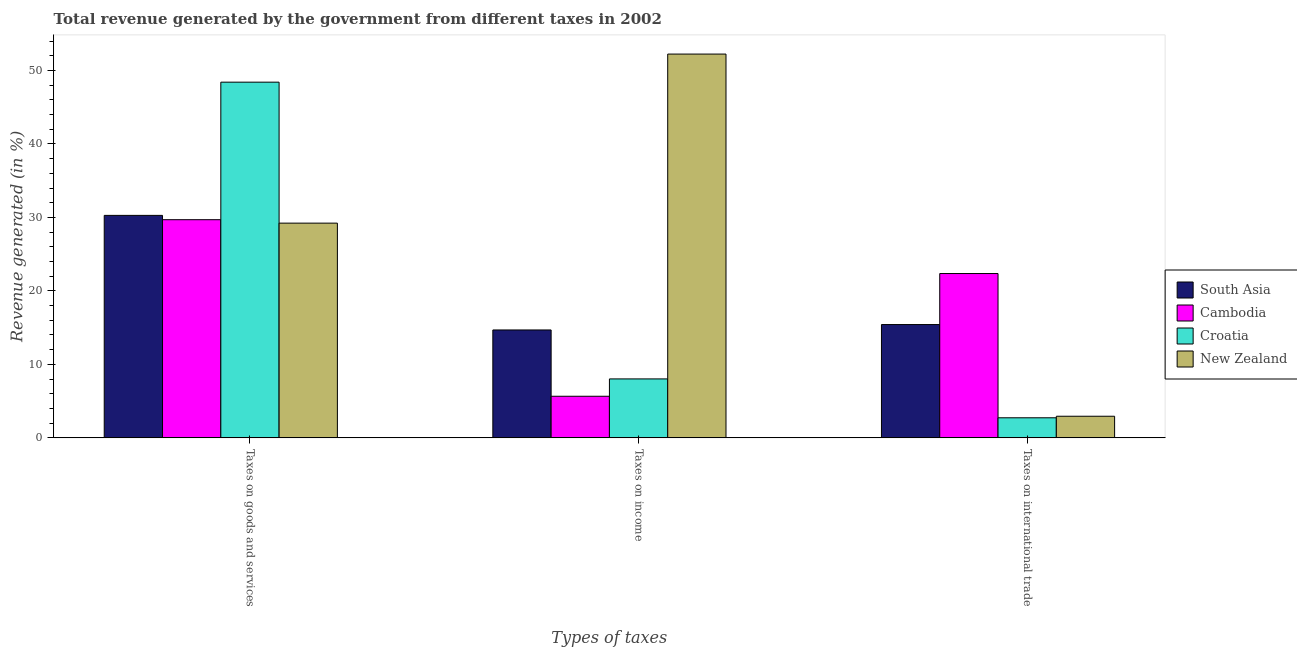How many groups of bars are there?
Keep it short and to the point. 3. How many bars are there on the 3rd tick from the left?
Ensure brevity in your answer.  4. How many bars are there on the 3rd tick from the right?
Ensure brevity in your answer.  4. What is the label of the 1st group of bars from the left?
Offer a terse response. Taxes on goods and services. What is the percentage of revenue generated by tax on international trade in Croatia?
Offer a terse response. 2.73. Across all countries, what is the maximum percentage of revenue generated by taxes on goods and services?
Give a very brief answer. 48.41. Across all countries, what is the minimum percentage of revenue generated by taxes on income?
Make the answer very short. 5.66. In which country was the percentage of revenue generated by tax on international trade maximum?
Offer a terse response. Cambodia. In which country was the percentage of revenue generated by taxes on goods and services minimum?
Your response must be concise. New Zealand. What is the total percentage of revenue generated by tax on international trade in the graph?
Give a very brief answer. 43.46. What is the difference between the percentage of revenue generated by taxes on income in Croatia and that in South Asia?
Provide a succinct answer. -6.66. What is the difference between the percentage of revenue generated by tax on international trade in South Asia and the percentage of revenue generated by taxes on income in New Zealand?
Ensure brevity in your answer.  -36.81. What is the average percentage of revenue generated by taxes on income per country?
Provide a short and direct response. 20.15. What is the difference between the percentage of revenue generated by taxes on income and percentage of revenue generated by tax on international trade in South Asia?
Offer a terse response. -0.74. What is the ratio of the percentage of revenue generated by taxes on income in New Zealand to that in Croatia?
Give a very brief answer. 6.51. Is the difference between the percentage of revenue generated by tax on international trade in New Zealand and South Asia greater than the difference between the percentage of revenue generated by taxes on income in New Zealand and South Asia?
Your answer should be very brief. No. What is the difference between the highest and the second highest percentage of revenue generated by taxes on goods and services?
Your answer should be compact. 18.13. What is the difference between the highest and the lowest percentage of revenue generated by taxes on income?
Give a very brief answer. 46.57. Is the sum of the percentage of revenue generated by taxes on income in New Zealand and Croatia greater than the maximum percentage of revenue generated by taxes on goods and services across all countries?
Your answer should be very brief. Yes. What does the 3rd bar from the left in Taxes on income represents?
Offer a terse response. Croatia. What does the 2nd bar from the right in Taxes on income represents?
Give a very brief answer. Croatia. How many bars are there?
Keep it short and to the point. 12. How many countries are there in the graph?
Your answer should be very brief. 4. What is the difference between two consecutive major ticks on the Y-axis?
Ensure brevity in your answer.  10. Are the values on the major ticks of Y-axis written in scientific E-notation?
Provide a short and direct response. No. Does the graph contain any zero values?
Offer a very short reply. No. Does the graph contain grids?
Make the answer very short. No. How are the legend labels stacked?
Your answer should be very brief. Vertical. What is the title of the graph?
Your response must be concise. Total revenue generated by the government from different taxes in 2002. Does "Cuba" appear as one of the legend labels in the graph?
Your response must be concise. No. What is the label or title of the X-axis?
Ensure brevity in your answer.  Types of taxes. What is the label or title of the Y-axis?
Provide a succinct answer. Revenue generated (in %). What is the Revenue generated (in %) of South Asia in Taxes on goods and services?
Your response must be concise. 30.28. What is the Revenue generated (in %) in Cambodia in Taxes on goods and services?
Your answer should be very brief. 29.69. What is the Revenue generated (in %) of Croatia in Taxes on goods and services?
Make the answer very short. 48.41. What is the Revenue generated (in %) of New Zealand in Taxes on goods and services?
Your response must be concise. 29.22. What is the Revenue generated (in %) in South Asia in Taxes on income?
Provide a short and direct response. 14.68. What is the Revenue generated (in %) of Cambodia in Taxes on income?
Your answer should be compact. 5.66. What is the Revenue generated (in %) in Croatia in Taxes on income?
Provide a short and direct response. 8.02. What is the Revenue generated (in %) of New Zealand in Taxes on income?
Your answer should be compact. 52.23. What is the Revenue generated (in %) of South Asia in Taxes on international trade?
Make the answer very short. 15.42. What is the Revenue generated (in %) of Cambodia in Taxes on international trade?
Your response must be concise. 22.36. What is the Revenue generated (in %) of Croatia in Taxes on international trade?
Make the answer very short. 2.73. What is the Revenue generated (in %) of New Zealand in Taxes on international trade?
Your answer should be compact. 2.94. Across all Types of taxes, what is the maximum Revenue generated (in %) in South Asia?
Your answer should be very brief. 30.28. Across all Types of taxes, what is the maximum Revenue generated (in %) in Cambodia?
Keep it short and to the point. 29.69. Across all Types of taxes, what is the maximum Revenue generated (in %) in Croatia?
Offer a very short reply. 48.41. Across all Types of taxes, what is the maximum Revenue generated (in %) in New Zealand?
Your answer should be compact. 52.23. Across all Types of taxes, what is the minimum Revenue generated (in %) in South Asia?
Provide a succinct answer. 14.68. Across all Types of taxes, what is the minimum Revenue generated (in %) of Cambodia?
Your answer should be very brief. 5.66. Across all Types of taxes, what is the minimum Revenue generated (in %) in Croatia?
Give a very brief answer. 2.73. Across all Types of taxes, what is the minimum Revenue generated (in %) in New Zealand?
Ensure brevity in your answer.  2.94. What is the total Revenue generated (in %) of South Asia in the graph?
Your response must be concise. 60.38. What is the total Revenue generated (in %) in Cambodia in the graph?
Offer a terse response. 57.72. What is the total Revenue generated (in %) in Croatia in the graph?
Offer a very short reply. 59.16. What is the total Revenue generated (in %) in New Zealand in the graph?
Provide a short and direct response. 84.39. What is the difference between the Revenue generated (in %) in South Asia in Taxes on goods and services and that in Taxes on income?
Provide a succinct answer. 15.59. What is the difference between the Revenue generated (in %) in Cambodia in Taxes on goods and services and that in Taxes on income?
Keep it short and to the point. 24.03. What is the difference between the Revenue generated (in %) of Croatia in Taxes on goods and services and that in Taxes on income?
Offer a very short reply. 40.38. What is the difference between the Revenue generated (in %) in New Zealand in Taxes on goods and services and that in Taxes on income?
Make the answer very short. -23.01. What is the difference between the Revenue generated (in %) in South Asia in Taxes on goods and services and that in Taxes on international trade?
Give a very brief answer. 14.86. What is the difference between the Revenue generated (in %) of Cambodia in Taxes on goods and services and that in Taxes on international trade?
Offer a terse response. 7.33. What is the difference between the Revenue generated (in %) in Croatia in Taxes on goods and services and that in Taxes on international trade?
Your answer should be very brief. 45.67. What is the difference between the Revenue generated (in %) of New Zealand in Taxes on goods and services and that in Taxes on international trade?
Keep it short and to the point. 26.28. What is the difference between the Revenue generated (in %) in South Asia in Taxes on income and that in Taxes on international trade?
Keep it short and to the point. -0.74. What is the difference between the Revenue generated (in %) in Cambodia in Taxes on income and that in Taxes on international trade?
Keep it short and to the point. -16.7. What is the difference between the Revenue generated (in %) in Croatia in Taxes on income and that in Taxes on international trade?
Your answer should be compact. 5.29. What is the difference between the Revenue generated (in %) of New Zealand in Taxes on income and that in Taxes on international trade?
Offer a terse response. 49.28. What is the difference between the Revenue generated (in %) in South Asia in Taxes on goods and services and the Revenue generated (in %) in Cambodia in Taxes on income?
Your response must be concise. 24.61. What is the difference between the Revenue generated (in %) of South Asia in Taxes on goods and services and the Revenue generated (in %) of Croatia in Taxes on income?
Ensure brevity in your answer.  22.25. What is the difference between the Revenue generated (in %) of South Asia in Taxes on goods and services and the Revenue generated (in %) of New Zealand in Taxes on income?
Your answer should be compact. -21.95. What is the difference between the Revenue generated (in %) in Cambodia in Taxes on goods and services and the Revenue generated (in %) in Croatia in Taxes on income?
Make the answer very short. 21.67. What is the difference between the Revenue generated (in %) in Cambodia in Taxes on goods and services and the Revenue generated (in %) in New Zealand in Taxes on income?
Offer a very short reply. -22.54. What is the difference between the Revenue generated (in %) of Croatia in Taxes on goods and services and the Revenue generated (in %) of New Zealand in Taxes on income?
Keep it short and to the point. -3.82. What is the difference between the Revenue generated (in %) in South Asia in Taxes on goods and services and the Revenue generated (in %) in Cambodia in Taxes on international trade?
Your answer should be very brief. 7.91. What is the difference between the Revenue generated (in %) of South Asia in Taxes on goods and services and the Revenue generated (in %) of Croatia in Taxes on international trade?
Keep it short and to the point. 27.54. What is the difference between the Revenue generated (in %) in South Asia in Taxes on goods and services and the Revenue generated (in %) in New Zealand in Taxes on international trade?
Your answer should be very brief. 27.33. What is the difference between the Revenue generated (in %) in Cambodia in Taxes on goods and services and the Revenue generated (in %) in Croatia in Taxes on international trade?
Your answer should be very brief. 26.96. What is the difference between the Revenue generated (in %) in Cambodia in Taxes on goods and services and the Revenue generated (in %) in New Zealand in Taxes on international trade?
Offer a terse response. 26.75. What is the difference between the Revenue generated (in %) in Croatia in Taxes on goods and services and the Revenue generated (in %) in New Zealand in Taxes on international trade?
Offer a terse response. 45.46. What is the difference between the Revenue generated (in %) in South Asia in Taxes on income and the Revenue generated (in %) in Cambodia in Taxes on international trade?
Offer a very short reply. -7.68. What is the difference between the Revenue generated (in %) of South Asia in Taxes on income and the Revenue generated (in %) of Croatia in Taxes on international trade?
Provide a short and direct response. 11.95. What is the difference between the Revenue generated (in %) of South Asia in Taxes on income and the Revenue generated (in %) of New Zealand in Taxes on international trade?
Offer a very short reply. 11.74. What is the difference between the Revenue generated (in %) in Cambodia in Taxes on income and the Revenue generated (in %) in Croatia in Taxes on international trade?
Make the answer very short. 2.93. What is the difference between the Revenue generated (in %) in Cambodia in Taxes on income and the Revenue generated (in %) in New Zealand in Taxes on international trade?
Provide a short and direct response. 2.72. What is the difference between the Revenue generated (in %) in Croatia in Taxes on income and the Revenue generated (in %) in New Zealand in Taxes on international trade?
Your answer should be very brief. 5.08. What is the average Revenue generated (in %) in South Asia per Types of taxes?
Offer a terse response. 20.13. What is the average Revenue generated (in %) of Cambodia per Types of taxes?
Give a very brief answer. 19.24. What is the average Revenue generated (in %) in Croatia per Types of taxes?
Give a very brief answer. 19.72. What is the average Revenue generated (in %) in New Zealand per Types of taxes?
Provide a short and direct response. 28.13. What is the difference between the Revenue generated (in %) in South Asia and Revenue generated (in %) in Cambodia in Taxes on goods and services?
Give a very brief answer. 0.59. What is the difference between the Revenue generated (in %) in South Asia and Revenue generated (in %) in Croatia in Taxes on goods and services?
Your answer should be very brief. -18.13. What is the difference between the Revenue generated (in %) of South Asia and Revenue generated (in %) of New Zealand in Taxes on goods and services?
Offer a terse response. 1.05. What is the difference between the Revenue generated (in %) of Cambodia and Revenue generated (in %) of Croatia in Taxes on goods and services?
Keep it short and to the point. -18.72. What is the difference between the Revenue generated (in %) of Cambodia and Revenue generated (in %) of New Zealand in Taxes on goods and services?
Keep it short and to the point. 0.47. What is the difference between the Revenue generated (in %) in Croatia and Revenue generated (in %) in New Zealand in Taxes on goods and services?
Give a very brief answer. 19.18. What is the difference between the Revenue generated (in %) in South Asia and Revenue generated (in %) in Cambodia in Taxes on income?
Offer a terse response. 9.02. What is the difference between the Revenue generated (in %) in South Asia and Revenue generated (in %) in Croatia in Taxes on income?
Provide a short and direct response. 6.66. What is the difference between the Revenue generated (in %) in South Asia and Revenue generated (in %) in New Zealand in Taxes on income?
Offer a very short reply. -37.54. What is the difference between the Revenue generated (in %) in Cambodia and Revenue generated (in %) in Croatia in Taxes on income?
Offer a very short reply. -2.36. What is the difference between the Revenue generated (in %) in Cambodia and Revenue generated (in %) in New Zealand in Taxes on income?
Make the answer very short. -46.57. What is the difference between the Revenue generated (in %) in Croatia and Revenue generated (in %) in New Zealand in Taxes on income?
Make the answer very short. -44.21. What is the difference between the Revenue generated (in %) in South Asia and Revenue generated (in %) in Cambodia in Taxes on international trade?
Make the answer very short. -6.94. What is the difference between the Revenue generated (in %) in South Asia and Revenue generated (in %) in Croatia in Taxes on international trade?
Ensure brevity in your answer.  12.69. What is the difference between the Revenue generated (in %) of South Asia and Revenue generated (in %) of New Zealand in Taxes on international trade?
Offer a terse response. 12.48. What is the difference between the Revenue generated (in %) of Cambodia and Revenue generated (in %) of Croatia in Taxes on international trade?
Ensure brevity in your answer.  19.63. What is the difference between the Revenue generated (in %) in Cambodia and Revenue generated (in %) in New Zealand in Taxes on international trade?
Provide a succinct answer. 19.42. What is the difference between the Revenue generated (in %) of Croatia and Revenue generated (in %) of New Zealand in Taxes on international trade?
Give a very brief answer. -0.21. What is the ratio of the Revenue generated (in %) in South Asia in Taxes on goods and services to that in Taxes on income?
Your answer should be compact. 2.06. What is the ratio of the Revenue generated (in %) in Cambodia in Taxes on goods and services to that in Taxes on income?
Your answer should be very brief. 5.24. What is the ratio of the Revenue generated (in %) of Croatia in Taxes on goods and services to that in Taxes on income?
Give a very brief answer. 6.03. What is the ratio of the Revenue generated (in %) in New Zealand in Taxes on goods and services to that in Taxes on income?
Provide a short and direct response. 0.56. What is the ratio of the Revenue generated (in %) of South Asia in Taxes on goods and services to that in Taxes on international trade?
Provide a short and direct response. 1.96. What is the ratio of the Revenue generated (in %) in Cambodia in Taxes on goods and services to that in Taxes on international trade?
Provide a short and direct response. 1.33. What is the ratio of the Revenue generated (in %) of Croatia in Taxes on goods and services to that in Taxes on international trade?
Offer a terse response. 17.72. What is the ratio of the Revenue generated (in %) in New Zealand in Taxes on goods and services to that in Taxes on international trade?
Give a very brief answer. 9.93. What is the ratio of the Revenue generated (in %) in South Asia in Taxes on income to that in Taxes on international trade?
Your answer should be compact. 0.95. What is the ratio of the Revenue generated (in %) in Cambodia in Taxes on income to that in Taxes on international trade?
Give a very brief answer. 0.25. What is the ratio of the Revenue generated (in %) in Croatia in Taxes on income to that in Taxes on international trade?
Offer a very short reply. 2.94. What is the ratio of the Revenue generated (in %) in New Zealand in Taxes on income to that in Taxes on international trade?
Your answer should be very brief. 17.74. What is the difference between the highest and the second highest Revenue generated (in %) of South Asia?
Your answer should be very brief. 14.86. What is the difference between the highest and the second highest Revenue generated (in %) in Cambodia?
Keep it short and to the point. 7.33. What is the difference between the highest and the second highest Revenue generated (in %) in Croatia?
Provide a short and direct response. 40.38. What is the difference between the highest and the second highest Revenue generated (in %) of New Zealand?
Provide a short and direct response. 23.01. What is the difference between the highest and the lowest Revenue generated (in %) in South Asia?
Provide a succinct answer. 15.59. What is the difference between the highest and the lowest Revenue generated (in %) of Cambodia?
Give a very brief answer. 24.03. What is the difference between the highest and the lowest Revenue generated (in %) in Croatia?
Keep it short and to the point. 45.67. What is the difference between the highest and the lowest Revenue generated (in %) of New Zealand?
Offer a very short reply. 49.28. 